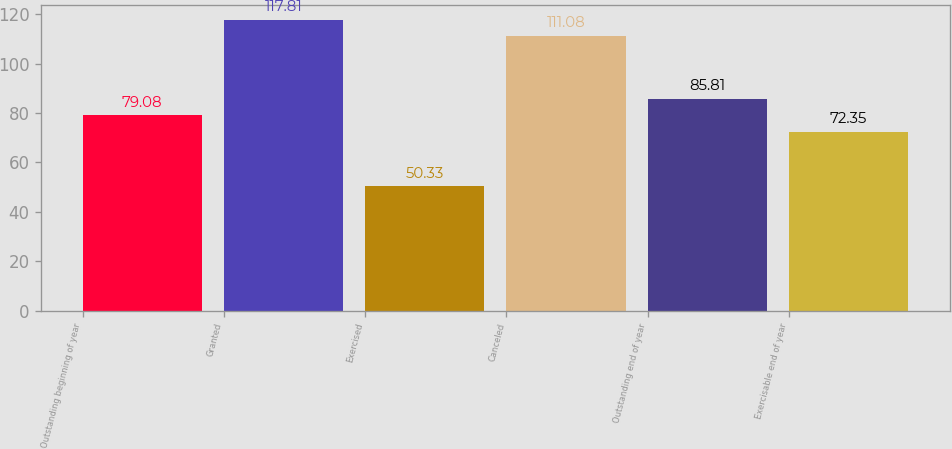Convert chart to OTSL. <chart><loc_0><loc_0><loc_500><loc_500><bar_chart><fcel>Outstanding beginning of year<fcel>Granted<fcel>Exercised<fcel>Canceled<fcel>Outstanding end of year<fcel>Exercisable end of year<nl><fcel>79.08<fcel>117.81<fcel>50.33<fcel>111.08<fcel>85.81<fcel>72.35<nl></chart> 